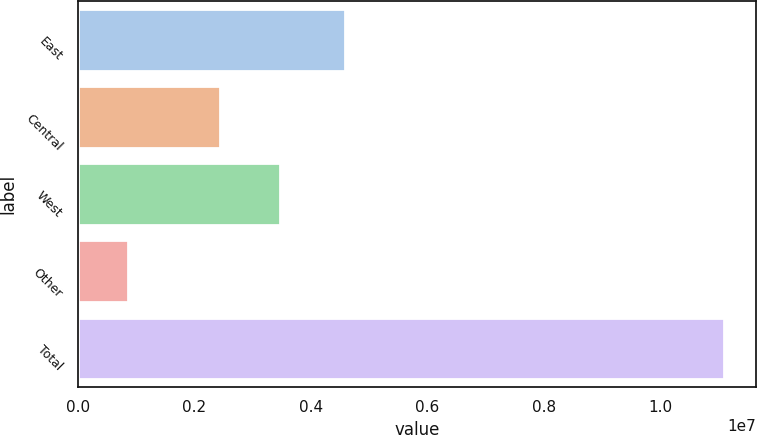Convert chart to OTSL. <chart><loc_0><loc_0><loc_500><loc_500><bar_chart><fcel>East<fcel>Central<fcel>West<fcel>Other<fcel>Total<nl><fcel>4.5773e+06<fcel>2.44492e+06<fcel>3.46707e+06<fcel>862657<fcel>1.10841e+07<nl></chart> 